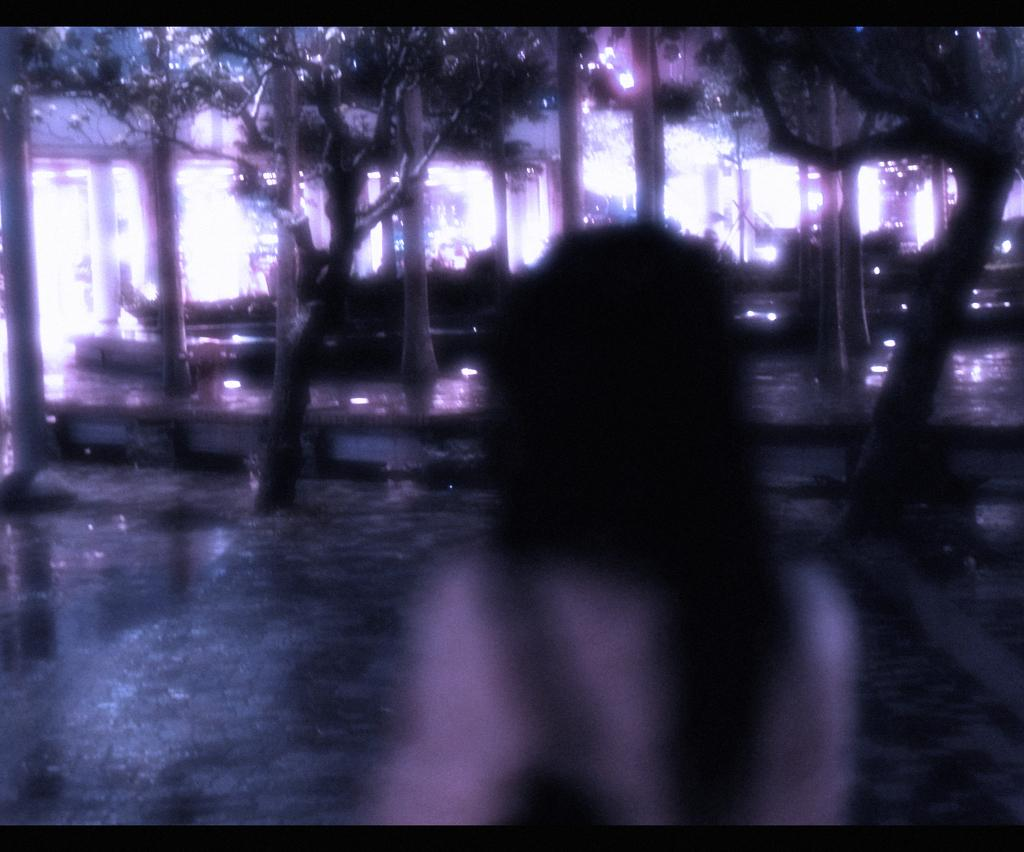What is the object in the image that resembles humans? The object in the image that resembles humans is not specified, but it could be a statue, sculpture, or other representation. What type of vegetation is present in the image? There are trees in the image. What type of pancake is being served at the picnic in the image? There is no picnic or pancake present in the image; it only features an object resembling humans and trees. 